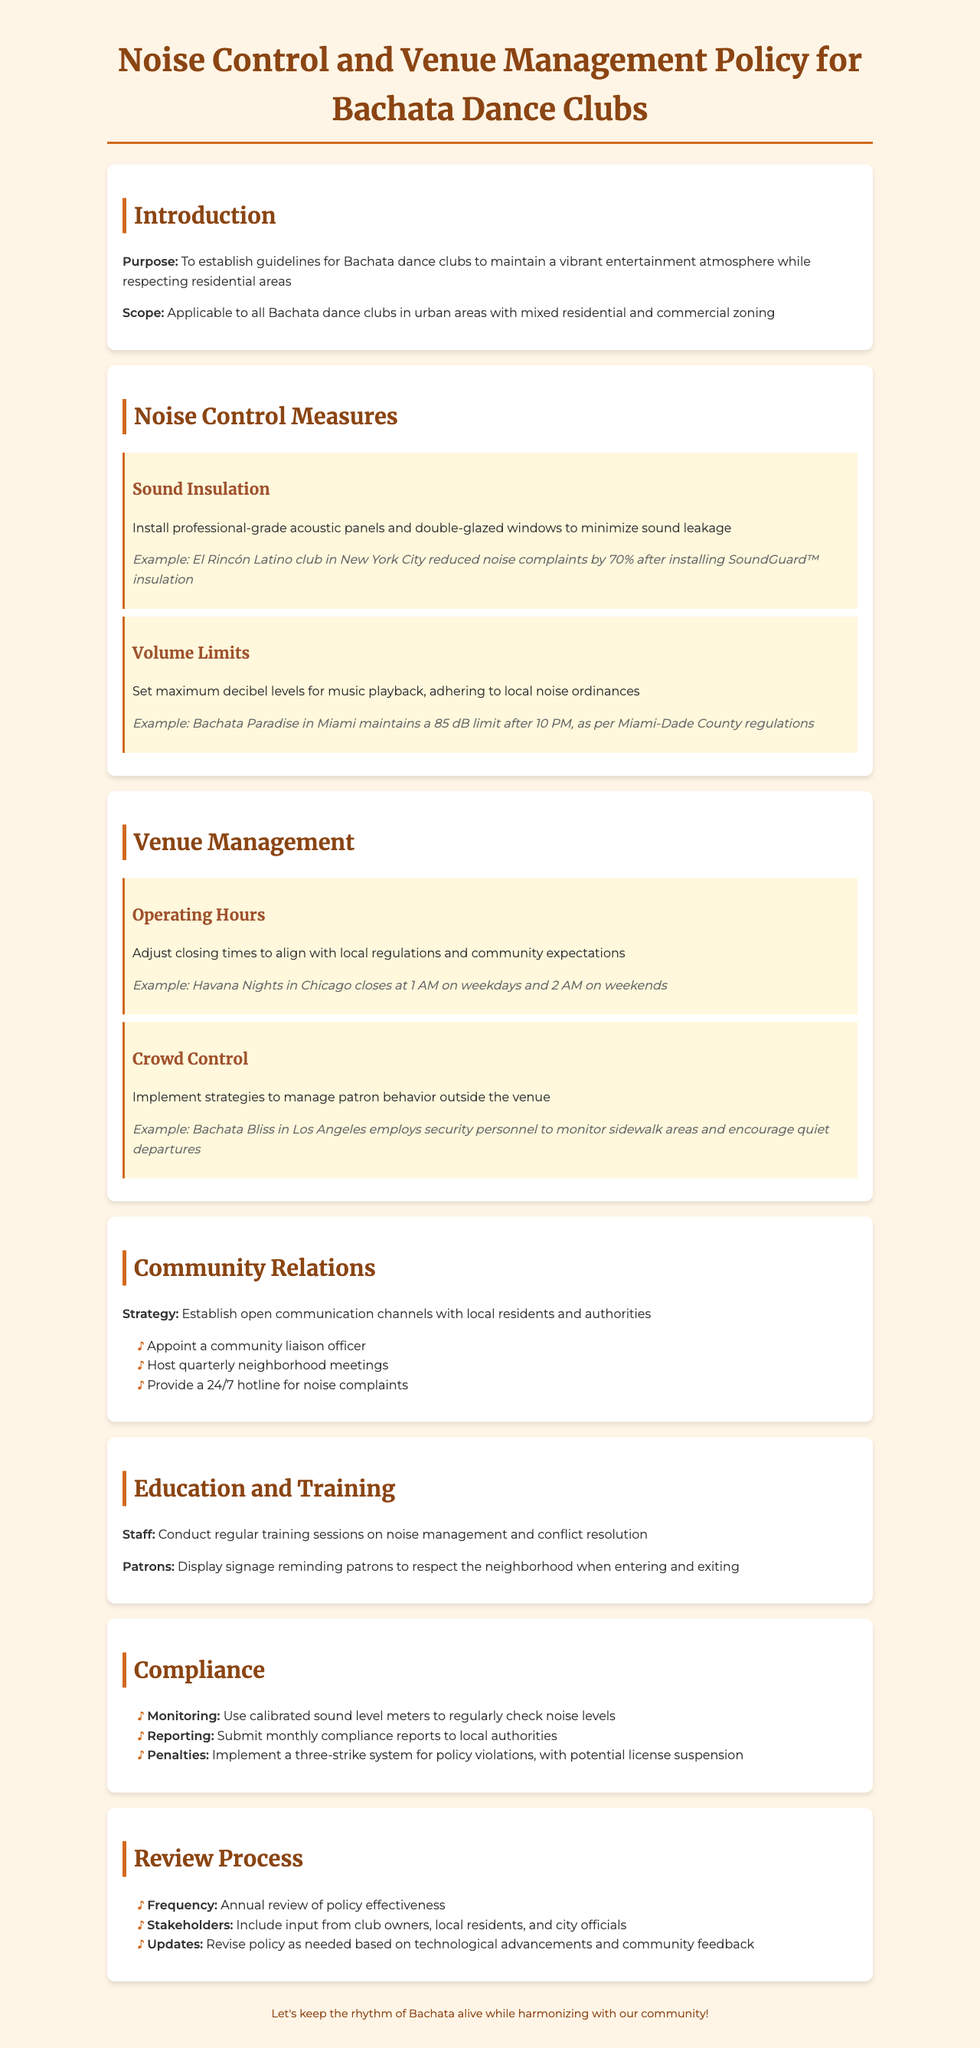What is the purpose of the policy? The purpose is to establish guidelines for Bachata dance clubs to maintain a vibrant entertainment atmosphere while respecting residential areas.
Answer: To establish guidelines for Bachata dance clubs to maintain a vibrant entertainment atmosphere while respecting residential areas What is one of the noise control measures mentioned? The document outlines various noise control measures, such as sound insulation.
Answer: Sound insulation What is the volume limit recommended after 10 PM? Referring to local regulations can give insights into decibel levels set for clubs, particularly after certain hours.
Answer: 85 dB When does Havana Nights close on weekdays? The operating hours for various clubs are specified, providing insight into their closing times.
Answer: 1 AM What role does the community liaison officer serve? The document emphasizes the importance of open communication channels with the community, highlighting key strategies such as appointing a liaison officer.
Answer: Community liaison officer What is the frequency of the policy review? Information about the review process states how often the policy should be evaluated for effectiveness.
Answer: Annual What is the penalty system mentioned in the compliance section? The compliance section outlines the consequences for policy violations, indicating the structure of the penalty system.
Answer: Three-strike system How are the stakeholders involved in the review process? The document specifies the input gathering from various stakeholders, which contributes to revising the policy.
Answer: Club owners, local residents, and city officials What type of signage is recommended for patrons? The document advises on displaying reminders to patrons, which help in managing noise and behavior around venues.
Answer: Signage reminding patrons to respect the neighborhood when entering and exiting 